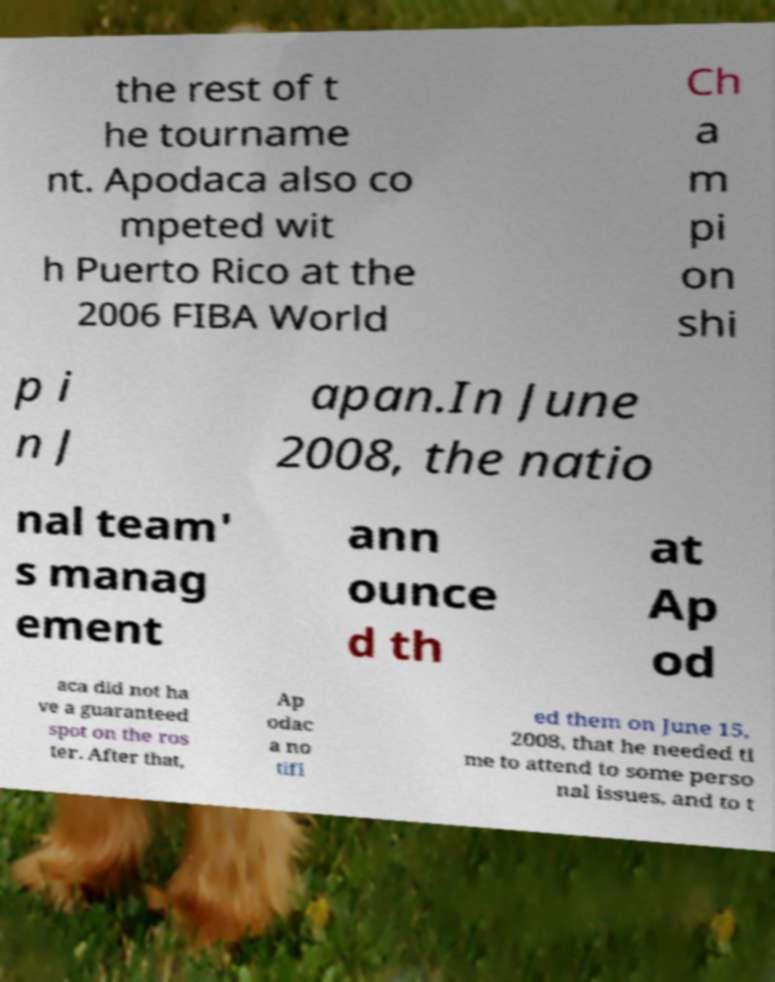For documentation purposes, I need the text within this image transcribed. Could you provide that? the rest of t he tourname nt. Apodaca also co mpeted wit h Puerto Rico at the 2006 FIBA World Ch a m pi on shi p i n J apan.In June 2008, the natio nal team' s manag ement ann ounce d th at Ap od aca did not ha ve a guaranteed spot on the ros ter. After that, Ap odac a no tifi ed them on June 15, 2008, that he needed ti me to attend to some perso nal issues, and to t 